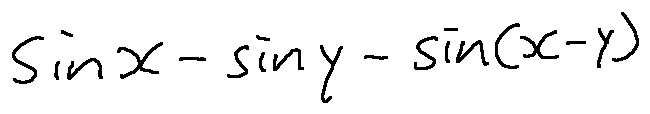<formula> <loc_0><loc_0><loc_500><loc_500>\sin x - \sin y - \sin ( x - y )</formula> 